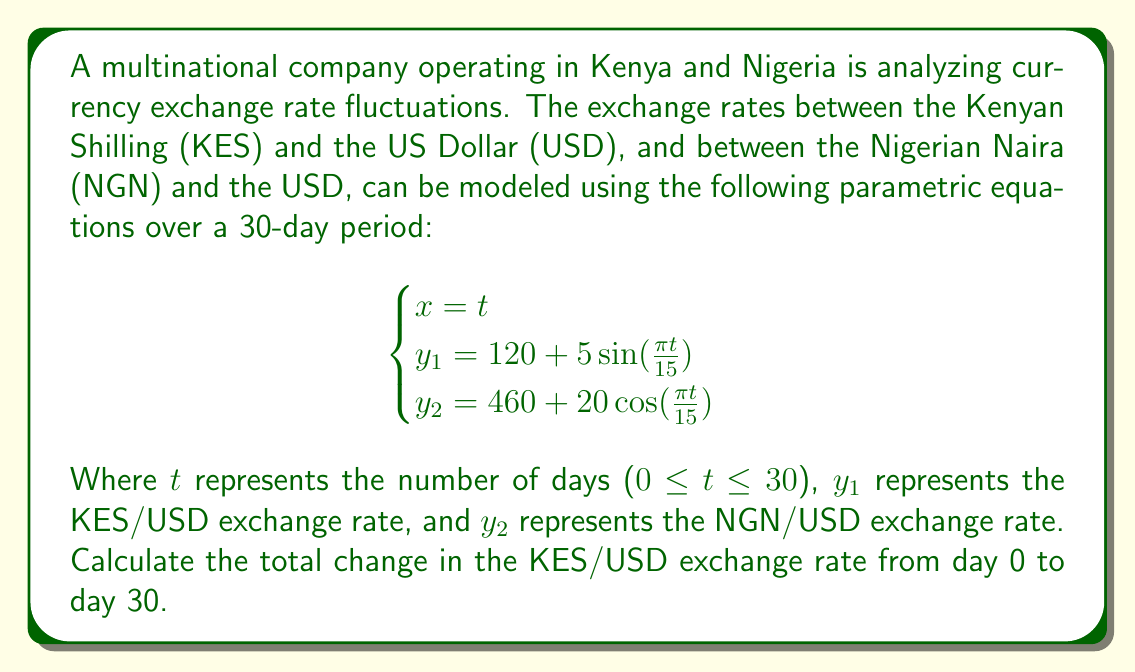Show me your answer to this math problem. To solve this problem, we need to follow these steps:

1) First, we need to calculate the exchange rate at day 0 and day 30 for the KES/USD rate.

2) For the KES/USD rate, we use the equation: $y_1 = 120 + 5\sin(\frac{\pi t}{15})$

3) At day 0:
   $y_1(0) = 120 + 5\sin(\frac{\pi \cdot 0}{15}) = 120 + 5\sin(0) = 120 + 0 = 120$

4) At day 30:
   $y_1(30) = 120 + 5\sin(\frac{\pi \cdot 30}{15}) = 120 + 5\sin(2\pi) = 120 + 0 = 120$

5) To find the total change, we subtract the initial value from the final value:
   Change = $y_1(30) - y_1(0) = 120 - 120 = 0$

6) Therefore, the total change in the KES/USD exchange rate from day 0 to day 30 is 0.

This result indicates that while the exchange rate fluctuates sinusoidally over the 30-day period, it returns to its initial value at the end of the period.
Answer: The total change in the KES/USD exchange rate from day 0 to day 30 is 0. 